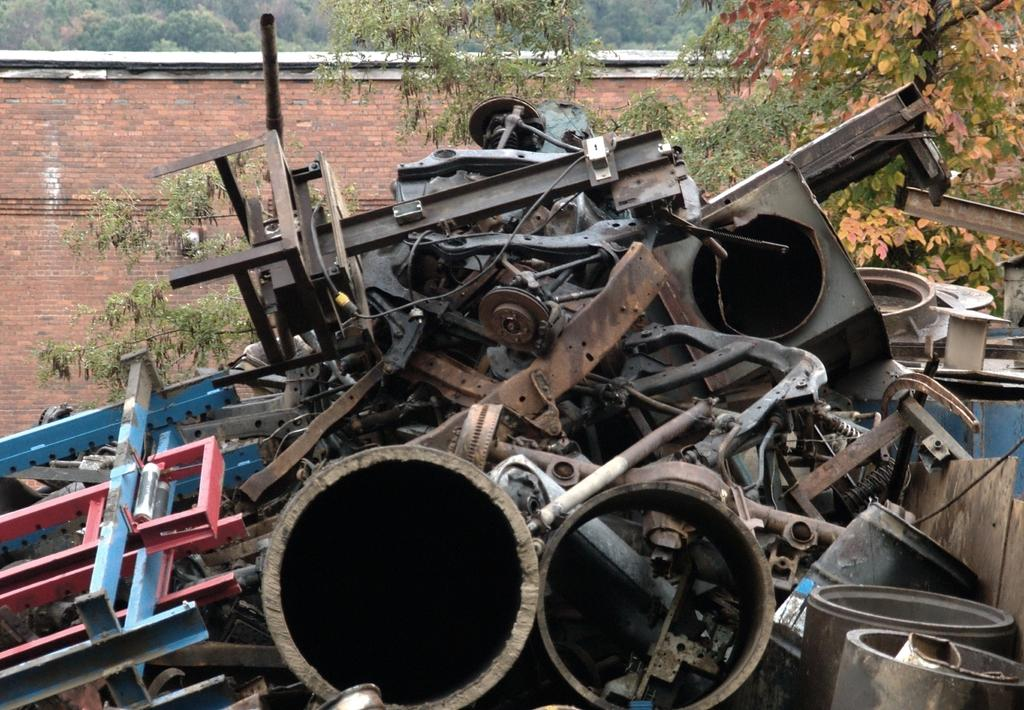What type of objects can be seen in the picture? There are scrap items in the picture. What is located behind the scrap items? There is a wall in the picture. What natural elements are present in the picture? There are trees in the picture. What temperature is the jail in the image? There is no jail present in the image, so it is not possible to determine the temperature. 